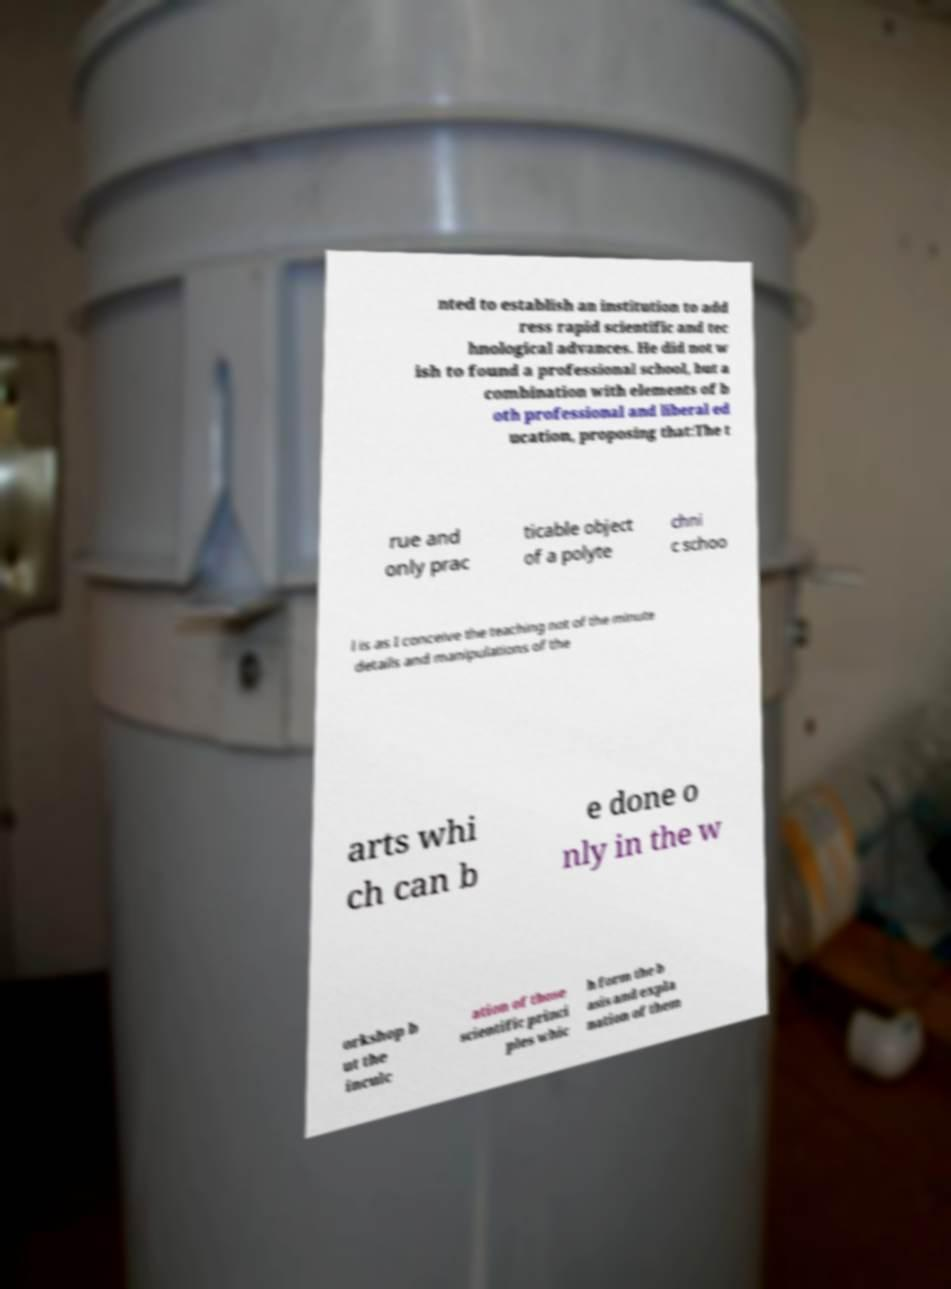Please read and relay the text visible in this image. What does it say? nted to establish an institution to add ress rapid scientific and tec hnological advances. He did not w ish to found a professional school, but a combination with elements of b oth professional and liberal ed ucation, proposing that:The t rue and only prac ticable object of a polyte chni c schoo l is as I conceive the teaching not of the minute details and manipulations of the arts whi ch can b e done o nly in the w orkshop b ut the inculc ation of those scientific princi ples whic h form the b asis and expla nation of them 